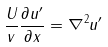<formula> <loc_0><loc_0><loc_500><loc_500>\frac { U } { v } \frac { \partial u ^ { \prime } } { \partial x } = \nabla ^ { 2 } u ^ { \prime }</formula> 